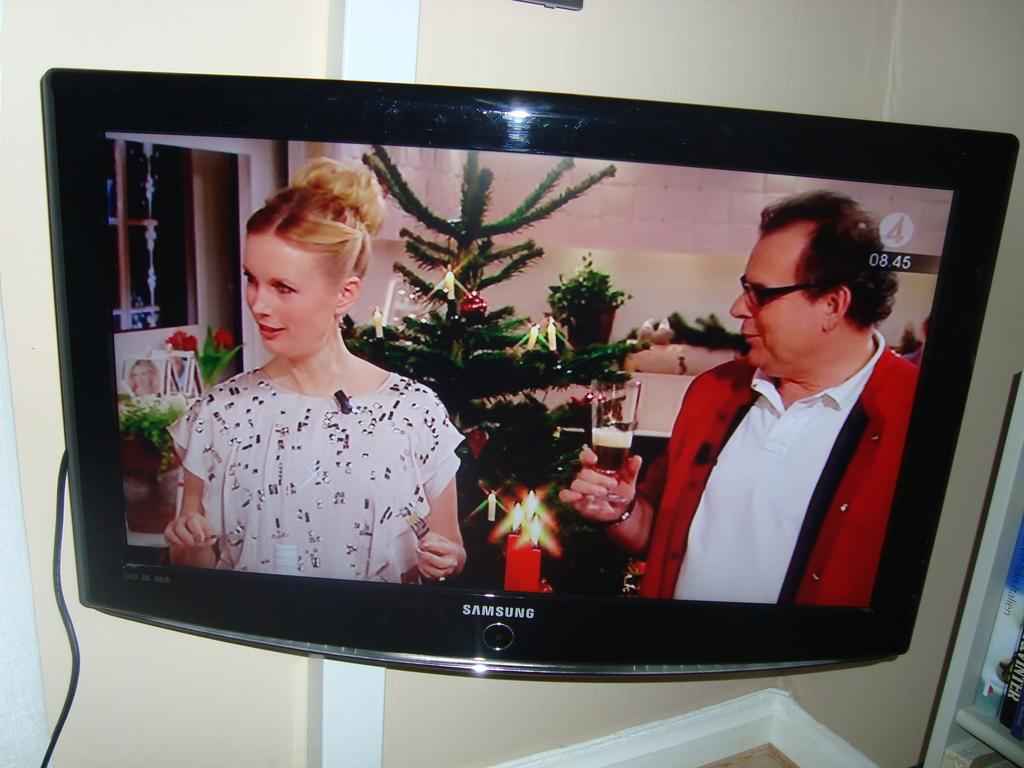What electronic device is present in the image? There is a television in the image. What is being displayed on the television screen? The television screen is displaying a man and a woman wearing clothes. What type of connection is visible in the image? There is a cable wire in the image. What type of structure is present in the image? There is a wall in the image. What type of scarf is the beggar wearing in the image? There is no beggar or scarf present in the image. What idea does the man on the television screen have about the woman's outfit? The image does not provide any information about the man's thoughts or ideas regarding the woman's outfit. 